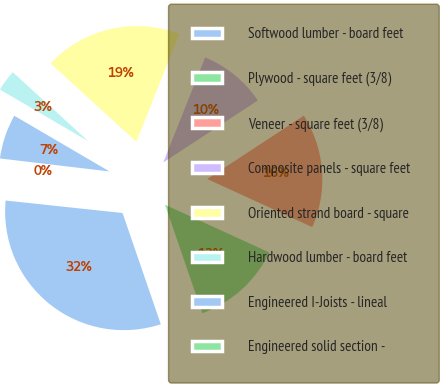Convert chart. <chart><loc_0><loc_0><loc_500><loc_500><pie_chart><fcel>Softwood lumber - board feet<fcel>Plywood - square feet (3/8)<fcel>Veneer - square feet (3/8)<fcel>Composite panels - square feet<fcel>Oriented strand board - square<fcel>Hardwood lumber - board feet<fcel>Engineered I-Joists - lineal<fcel>Engineered solid section -<nl><fcel>31.96%<fcel>12.9%<fcel>16.07%<fcel>9.72%<fcel>19.25%<fcel>3.36%<fcel>6.54%<fcel>0.19%<nl></chart> 